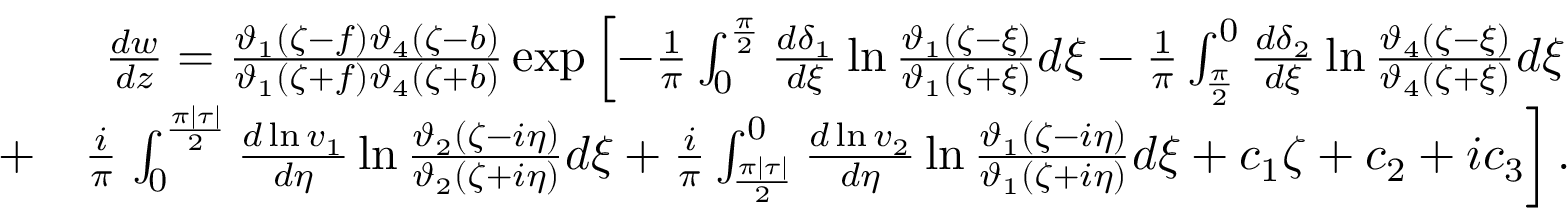Convert formula to latex. <formula><loc_0><loc_0><loc_500><loc_500>\begin{array} { r l r } & { \frac { d w } { d z } = \frac { \vartheta _ { 1 } ( \zeta - f ) \vartheta _ { 4 } ( \zeta - b ) } { \vartheta _ { 1 } ( \zeta + f ) \vartheta _ { 4 } ( \zeta + b ) } \exp \left [ - \frac { 1 } { \pi } \int _ { 0 } ^ { \frac { \pi } { 2 } } \frac { d \delta _ { 1 } } { d \xi } \ln \frac { \vartheta _ { 1 } ( \zeta - \xi ) } { \vartheta _ { 1 } ( \zeta + \xi ) } d \xi - \frac { 1 } { \pi } \int _ { \frac { \pi } { 2 } } ^ { 0 } \frac { d \delta _ { 2 } } { d \xi } \ln \frac { \vartheta _ { 4 } ( \zeta - \xi ) } { \vartheta _ { 4 } ( \zeta + \xi ) } d \xi } \\ & { + } & { \frac { i } { \pi } \int _ { 0 } ^ { \frac { \pi | \tau | } { 2 } } \frac { d \ln v _ { 1 } } { d \eta } \ln \frac { \vartheta _ { 2 } ( \zeta - i \eta ) } { \vartheta _ { 2 } ( \zeta + i \eta ) } d \xi + \frac { i } { \pi } \int _ { \frac { \pi | \tau | } { 2 } } ^ { 0 } \frac { d \ln v _ { 2 } } { d \eta } \ln \frac { \vartheta _ { 1 } ( \zeta - i \eta ) } { \vartheta _ { 1 } ( \zeta + i \eta ) } d \xi + c _ { 1 } \zeta + c _ { 2 } + i c _ { 3 } \right ] . } \end{array}</formula> 